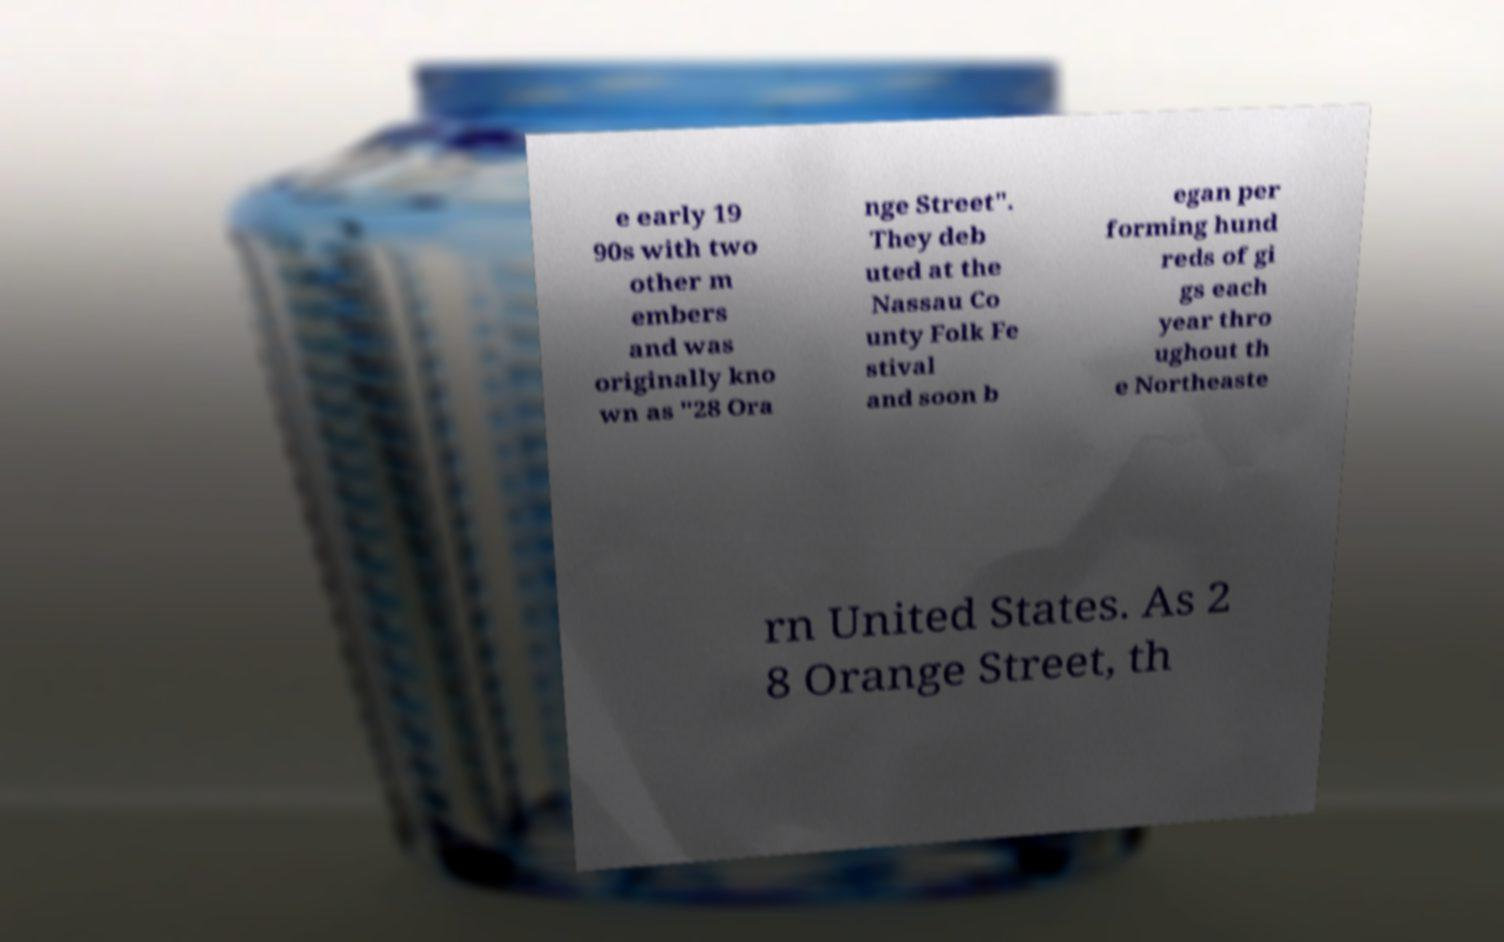What messages or text are displayed in this image? I need them in a readable, typed format. e early 19 90s with two other m embers and was originally kno wn as "28 Ora nge Street". They deb uted at the Nassau Co unty Folk Fe stival and soon b egan per forming hund reds of gi gs each year thro ughout th e Northeaste rn United States. As 2 8 Orange Street, th 